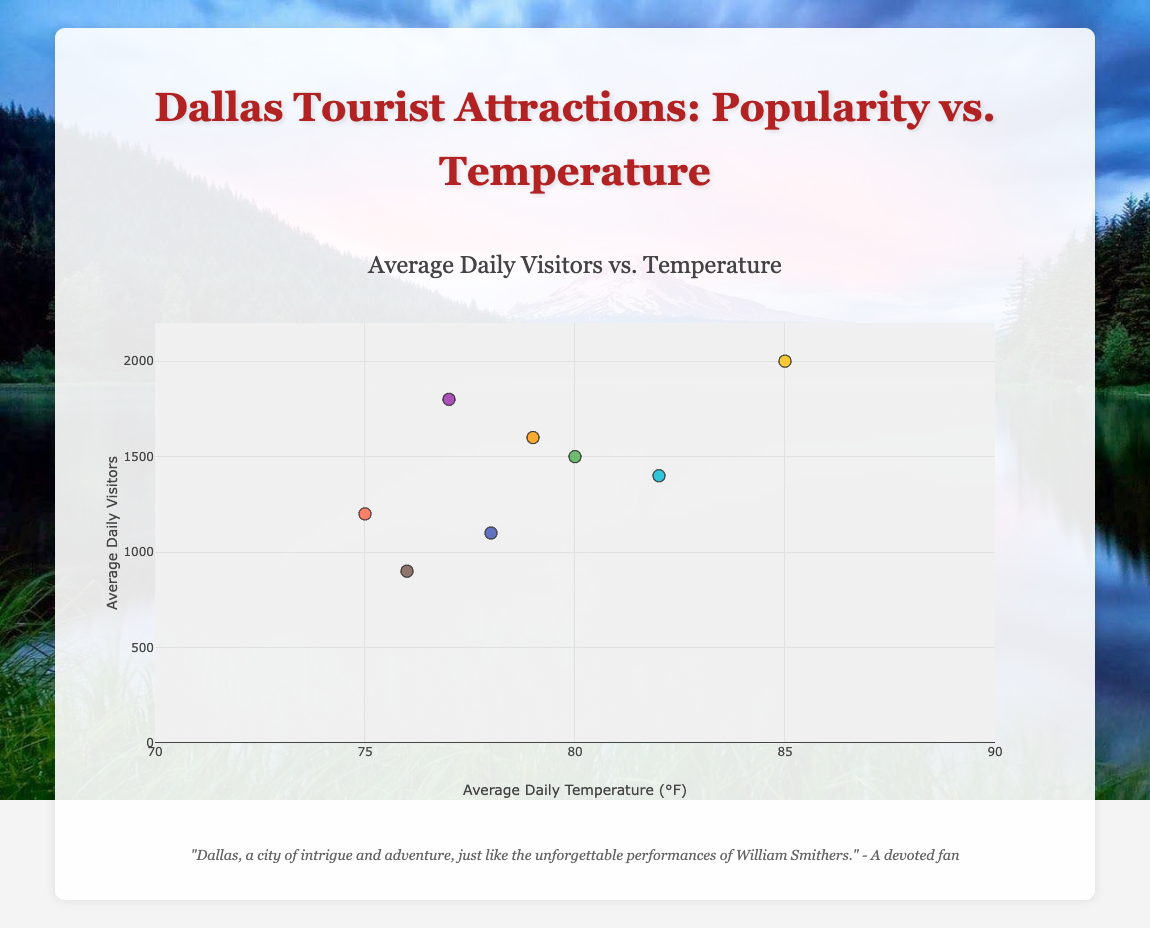what is the title of the plot? The title of the plot is given at the top and should directly state the subject of the visualization. The title is usually one of the first elements you see when looking at a graph.
Answer: Average Daily Visitors vs. Temperature what is the average number of daily visitors to the Dallas Museum of Art? By hovering over the point on the scatter plot associated with the Dallas Museum of Art, the hover info will display the exact number of daily visitors and other details about that point.
Answer: 900 which tourist attraction has the highest average daily temperature? By examining the x-axis values, the highest x-axis value represents the highest average daily temperature. Hovering over the points can reveal that the Dallas Zoo has the highest average daily temperature.
Answer: Dallas Zoo how many attractions have an average daily temperature above 80°F? By looking at the x-axis and counting the number of points to the right of the 80°F mark, we can determine the number of attractions above that temperature. Three attractions (Dallas Arboretum and Botanical Garden, Dallas Zoo, Klyde Warren Park) fall into this category.
Answer: 3 what is the difference in average daily visitors between the Dallas Zoo and the Perot Museum of Nature and Science? First, get the values for the Dallas Zoo (2000) and the Perot Museum of Nature and Science (1100) by referring to their respective points on the plot. Then, calculate the difference: 2000 - 1100.
Answer: 900 is there a trend between average daily temperature and average daily visitors? Observing the scatter plot, one can look for a pattern or trend by comparing how changes in temperature (x-axis) relate to changes in visitor numbers (y-axis). Although not perfectly linear, one general trend seems to be that higher temperatures correspond to higher numbers of visitors.
Answer: Yes, there is a trend which attraction has the most similar average daily visitors to Reunion Tower? By examining the y-values and hovering over the points, we can see which other point is closest to the y-value of Reunion Tower (1800 visitors). Fair Park is closest with 1600 visitors.
Answer: Fair Park what is the range of average daily temperatures for the listed tourist attractions? To find the range, note the lowest and highest x-axis values and then subtract the lowest from the highest. The range is from 75°F (The Sixth Floor Museum at Dealey Plaza) to 85°F (Dallas Zoo).
Answer: 10°F which attraction has the lowest number of daily visitors? By identifying the point with the lowest y-value, it can be seen that the Dallas Museum of Art, with 900 visitors, has the least visitors.
Answer: Dallas Museum of Art how does the popularity of the Perot Museum of Nature and Science compare with the Dallas Arboretum and Botanical Garden? By comparing their y-values on the plot, it's clear that the Perot Museum of Nature and Science has 1100 visitors while the Dallas Arboretum and Botanical Garden has 1500 visitors. Hence, the Dallas Arboretum and Botanical Garden is more popular.
Answer: The Dallas Arboretum and Botanical Garden is more popular 